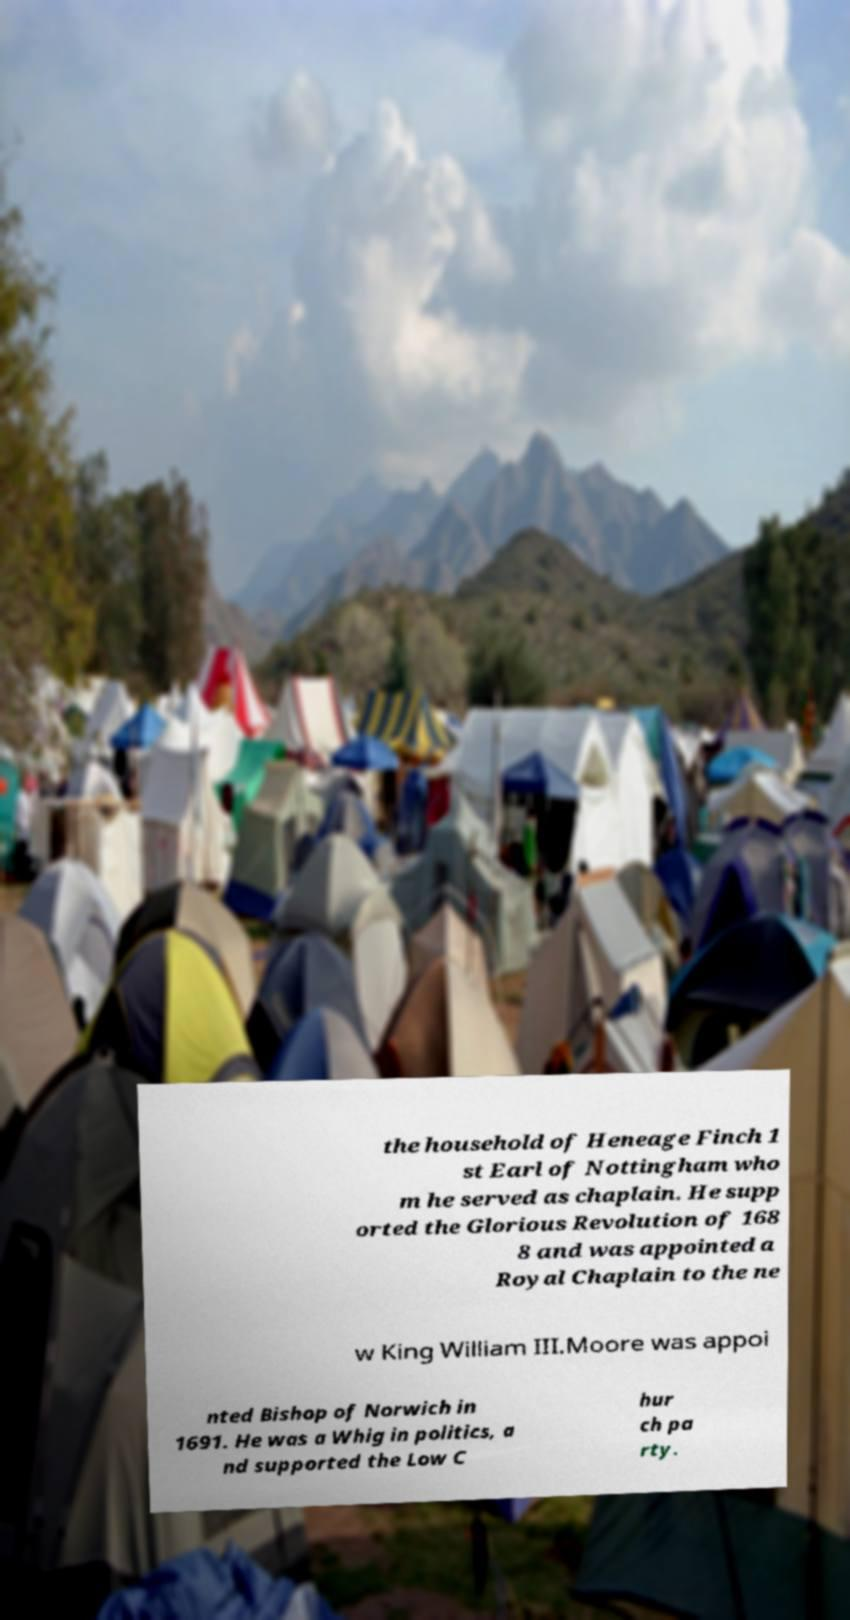Please read and relay the text visible in this image. What does it say? the household of Heneage Finch 1 st Earl of Nottingham who m he served as chaplain. He supp orted the Glorious Revolution of 168 8 and was appointed a Royal Chaplain to the ne w King William III.Moore was appoi nted Bishop of Norwich in 1691. He was a Whig in politics, a nd supported the Low C hur ch pa rty. 